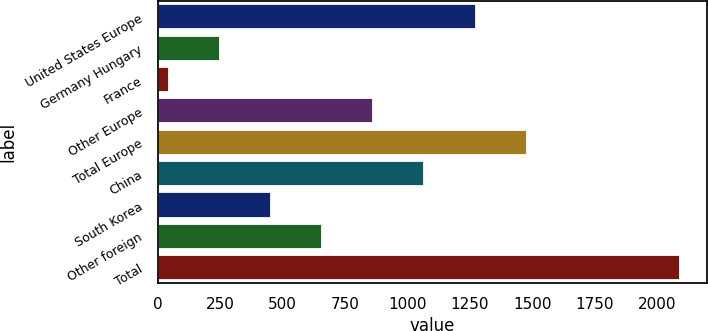<chart> <loc_0><loc_0><loc_500><loc_500><bar_chart><fcel>United States Europe<fcel>Germany Hungary<fcel>France<fcel>Other Europe<fcel>Total Europe<fcel>China<fcel>South Korea<fcel>Other foreign<fcel>Total<nl><fcel>1273.34<fcel>247.64<fcel>42.5<fcel>863.06<fcel>1478.48<fcel>1068.2<fcel>452.78<fcel>657.92<fcel>2093.9<nl></chart> 